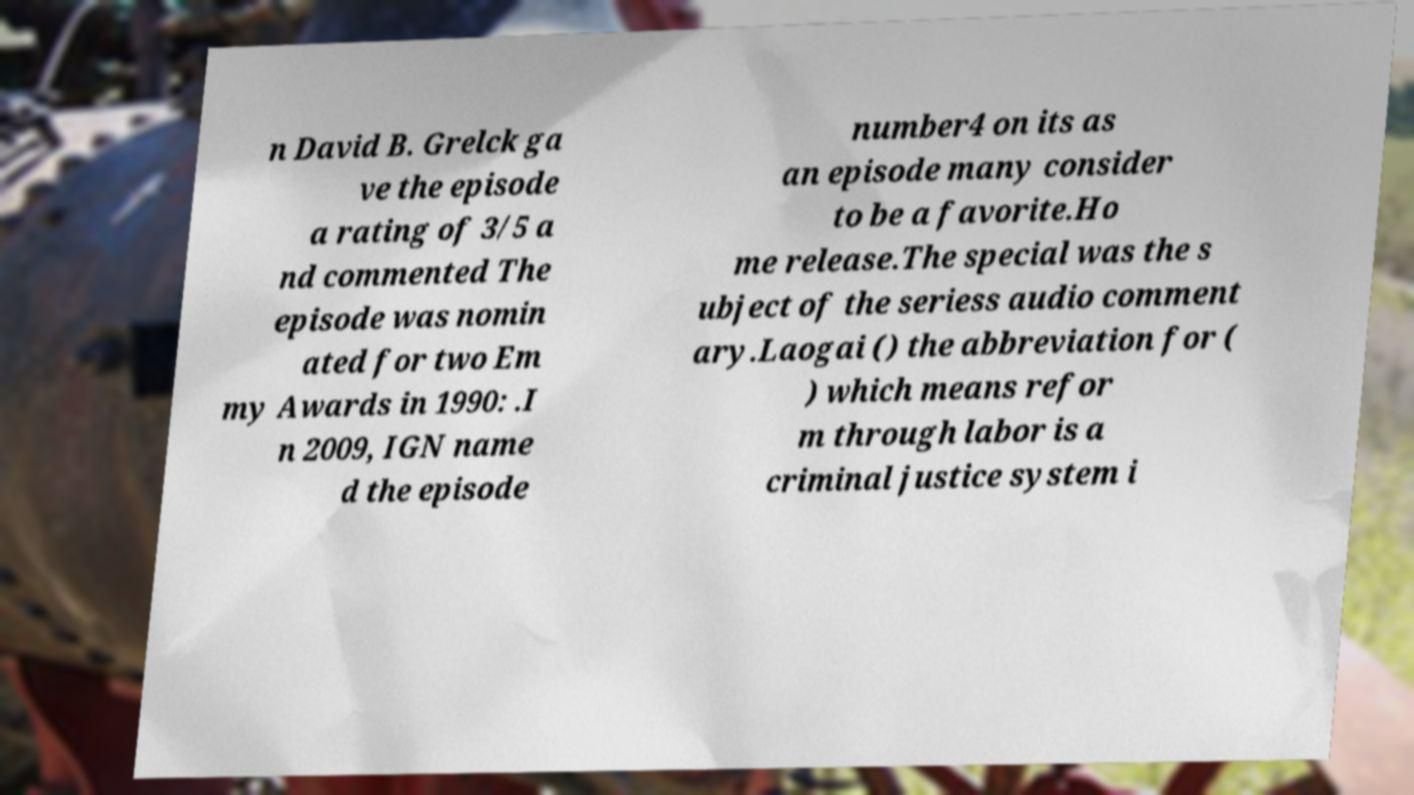What messages or text are displayed in this image? I need them in a readable, typed format. n David B. Grelck ga ve the episode a rating of 3/5 a nd commented The episode was nomin ated for two Em my Awards in 1990: .I n 2009, IGN name d the episode number4 on its as an episode many consider to be a favorite.Ho me release.The special was the s ubject of the seriess audio comment ary.Laogai () the abbreviation for ( ) which means refor m through labor is a criminal justice system i 